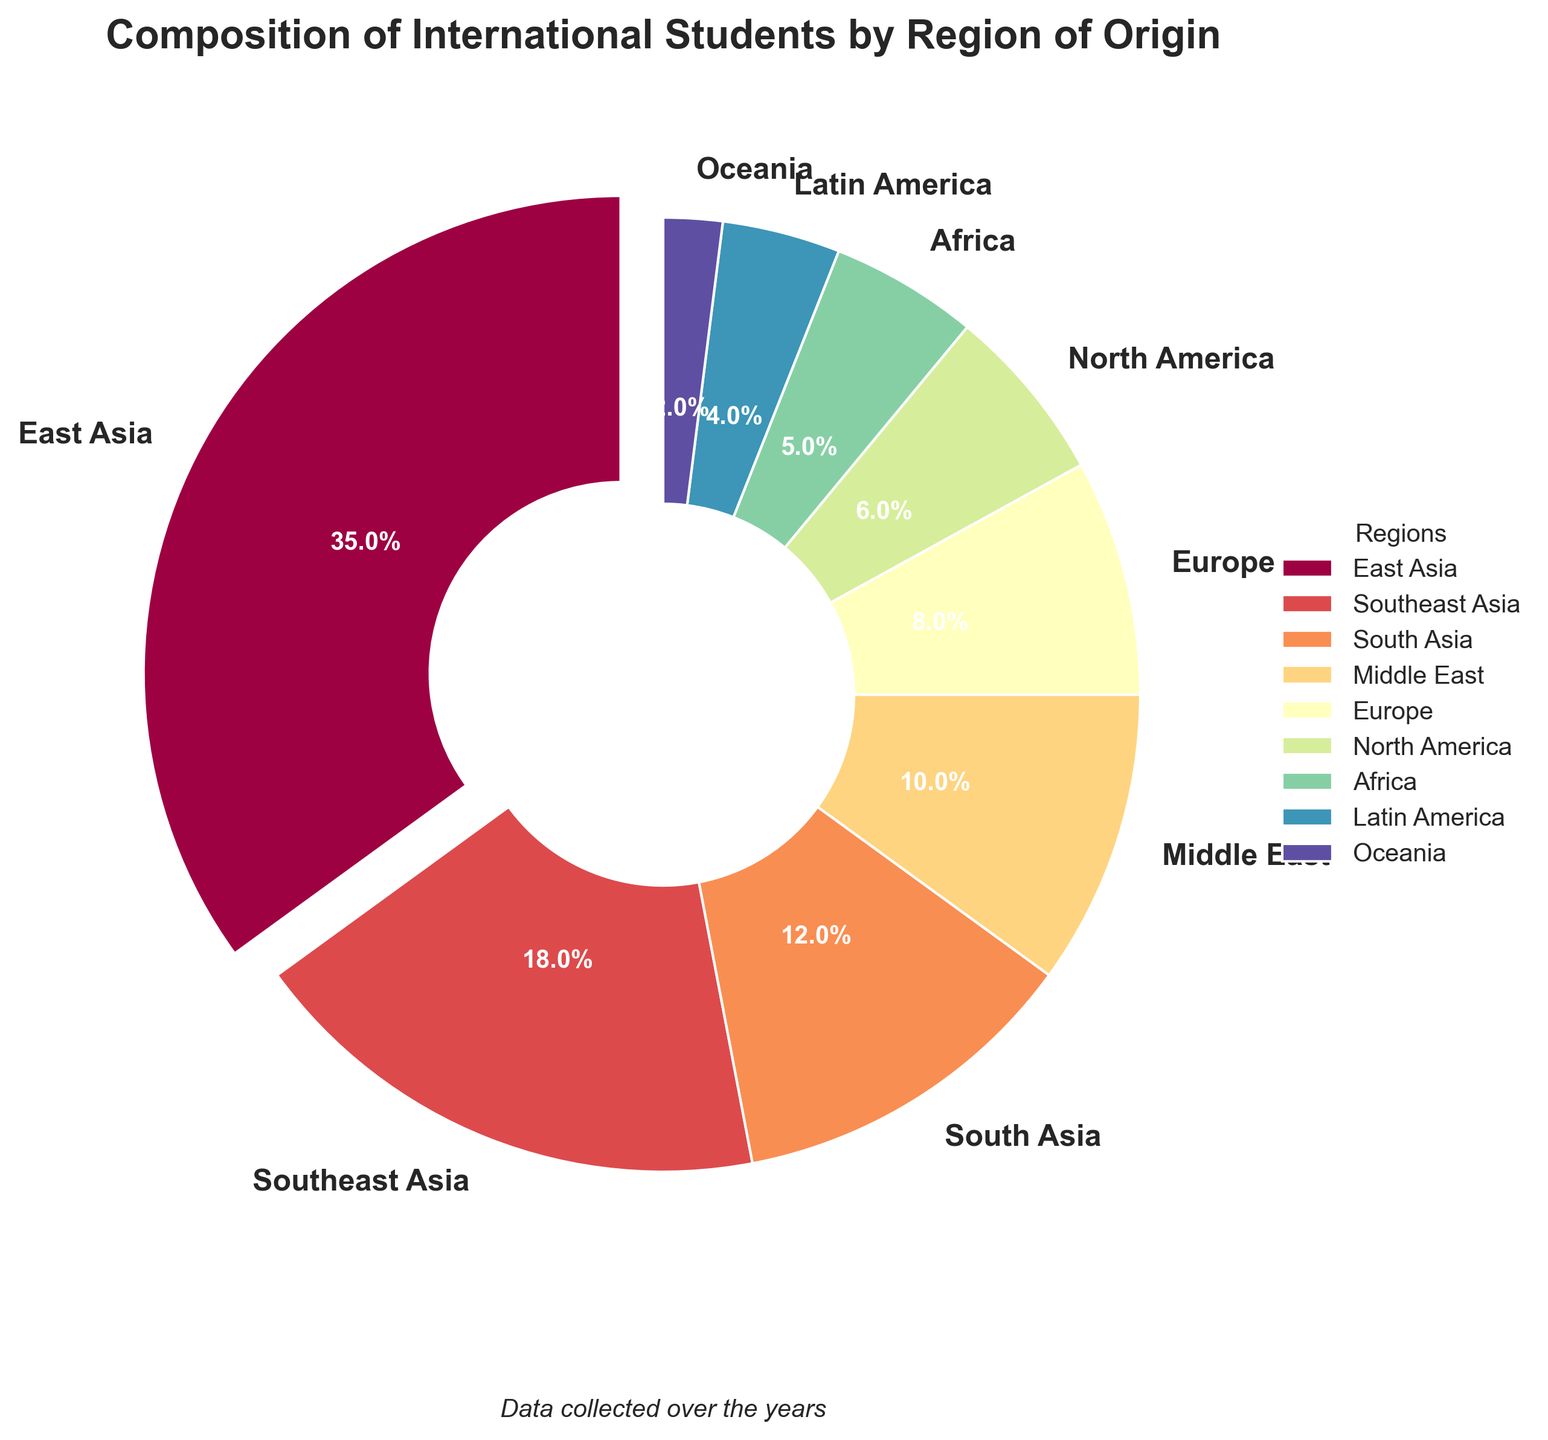What region has the highest percentage of international students? The region with the highest percentage is visually identified by the largest wedge in the pie chart, which is East Asia, making up 35% of the students.
Answer: East Asia Which region has more students, South Asia or Africa? Compare the wedge sizes for South Asia and Africa; South Asia has a larger percentage (12%) compared to Africa (5%).
Answer: South Asia What is the combined percentage of students from Europe and North America? Add the percentages of Europe and North America, which are 8% and 6% respectively, resulting in 8 + 6 = 14%.
Answer: 14% How does the percentage of students from Southeast Asia compare to that of Latin America? The wedge for Southeast Asia is larger than that for Latin America, indicating a higher percentage (18%) for Southeast Asia compared to 4% for Latin America.
Answer: Southeast Asia has a higher percentage What is the difference in the percentage of students from Oceania and the Middle East? Subtract the percentage of Oceania (2%) from that of the Middle East (10%), resulting in 10 - 2 = 8%.
Answer: 8% Which regions have a percentage of international students less than 10%? The regions with wedges representing less than 10% are Europe (8%), North America (6%), Africa (5%), Latin America (4%), and Oceania (2%).
Answer: Europe, North America, Africa, Latin America, Oceania Which region's percentage is closest to the average percentage of all regions? Calculate the average percentage by summing all percentages and dividing by the number of regions: (35 + 18 + 12 + 10 + 8 + 6 + 5 + 4 + 2) / 9 ≈ 11.1%. The closest region to this value is South Asia with 12%.
Answer: South Asia How much higher is the percentage of students from East Asia compared to North America? Subtract North America's percentage (6%) from East Asia's (35%), resulting in 35 - 6 = 29%.
Answer: 29% Identify the regions that make up exactly 50% of the student population when combined. Starting from the largest, East Asia (35%) and Southeast Asia (18%) together total 53%. Using East Asia (35%) and South Asia (12%) gives 47%. The closest without exceeding 50% is East Asia (35%) and Middle East (10%) which totals 45%. There's no exact combination reaching 50%. So the answer is "None."
Answer: None 